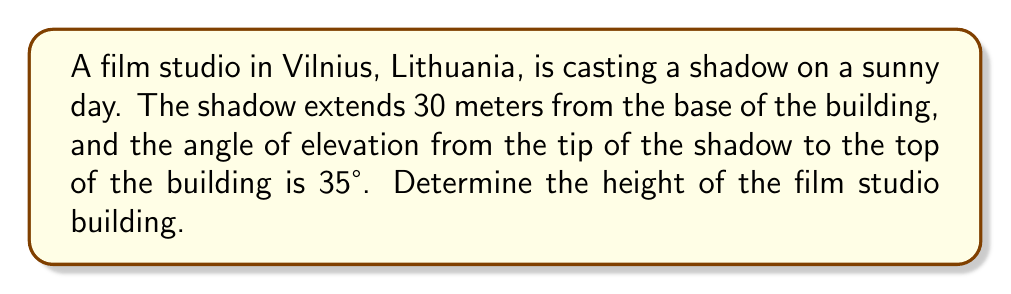Could you help me with this problem? Let's approach this step-by-step:

1) We can visualize this as a right triangle, where:
   - The shadow length is the base of the triangle
   - The height of the building is the opposite side
   - The hypotenuse is the line from the tip of the shadow to the top of the building

2) We know:
   - The adjacent side (shadow length) = 30 meters
   - The angle of elevation = 35°

3) We need to find the opposite side (height of the building)

4) In this scenario, we can use the tangent function:

   $$\tan \theta = \frac{\text{opposite}}{\text{adjacent}}$$

5) Substituting our known values:

   $$\tan 35° = \frac{\text{height}}{30}$$

6) To solve for height, we multiply both sides by 30:

   $$30 \cdot \tan 35° = \text{height}$$

7) Now we can calculate:
   $$\text{height} = 30 \cdot \tan 35° \approx 30 \cdot 0.7002 \approx 21.006$$

8) Rounding to the nearest decimeter:

   $$\text{height} \approx 21.0 \text{ meters}$$

[asy]
import geometry;

size(200);
pair A=(0,0), B=(6,0), C=(6,4.2);
draw(A--B--C--A);
draw(rightanglemark(A,B,C,20));
label("30 m",B/2,S);
label("35°",A,NW);
label("?",C/2,E);
[/asy]
Answer: 21.0 m 